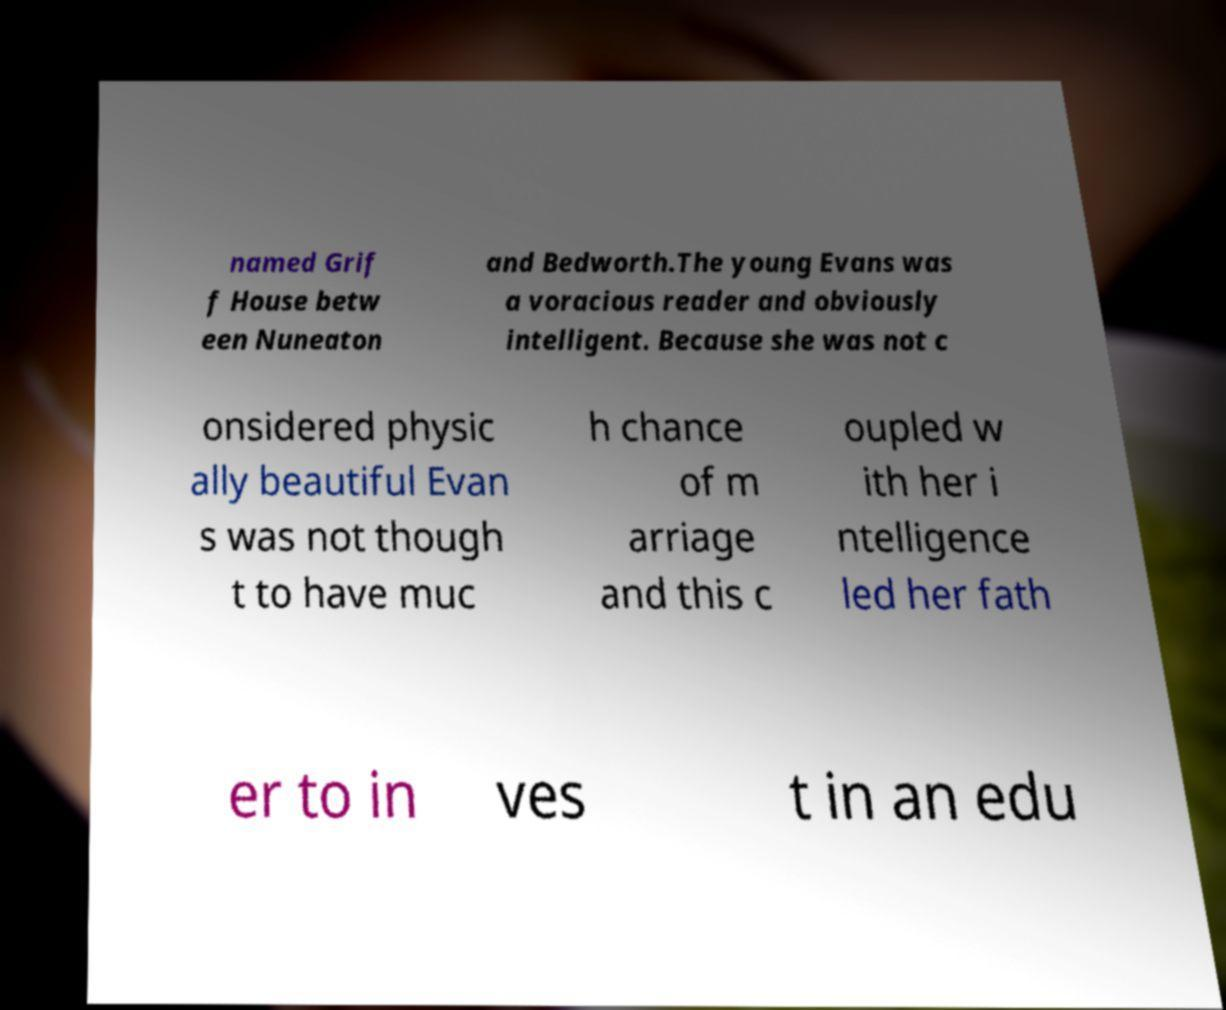Could you assist in decoding the text presented in this image and type it out clearly? named Grif f House betw een Nuneaton and Bedworth.The young Evans was a voracious reader and obviously intelligent. Because she was not c onsidered physic ally beautiful Evan s was not though t to have muc h chance of m arriage and this c oupled w ith her i ntelligence led her fath er to in ves t in an edu 